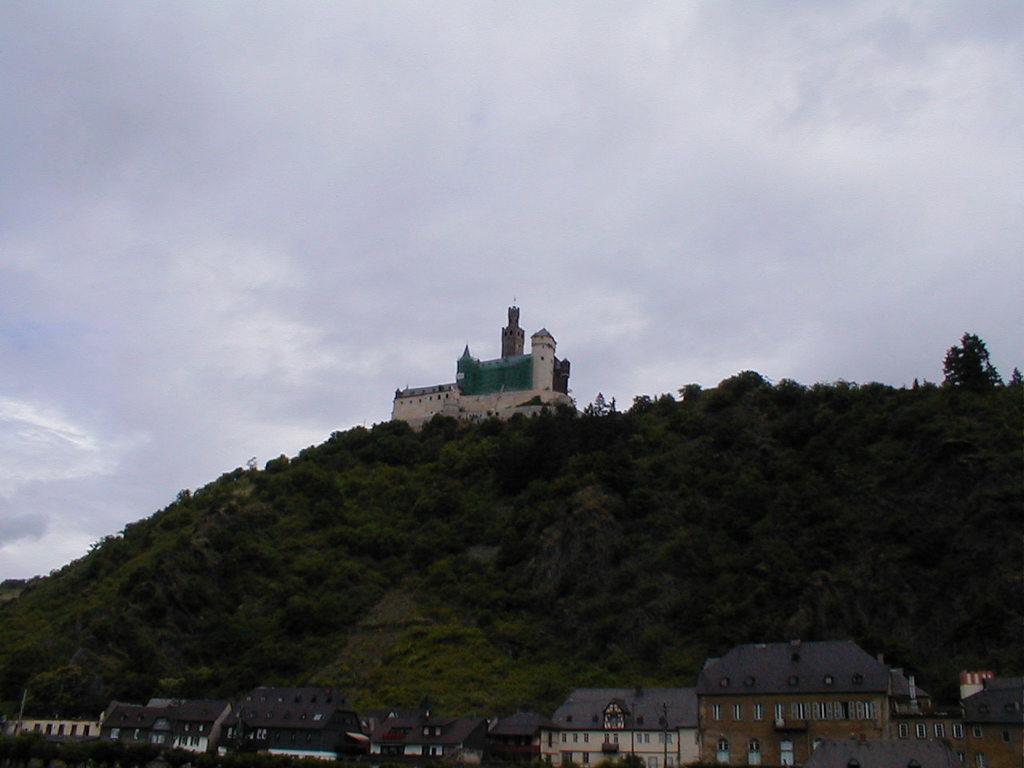Could you give a brief overview of what you see in this image? There are some houses at the bottom of this image, and there are some trees on the mountains in the background. There is a building on the mountain as we can see in the middle of this image. There is a sky at the top of this image. 